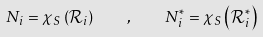<formula> <loc_0><loc_0><loc_500><loc_500>N _ { i } = \mathcal { \chi } _ { S } \left ( \mathcal { R } _ { i } \right ) \quad , \quad N _ { i } ^ { \ast } = \mathcal { \chi } _ { S } \left ( \mathcal { R } _ { i } ^ { \ast } \right )</formula> 